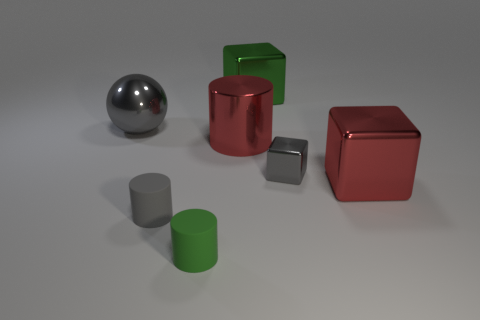Subtract all big metal cubes. How many cubes are left? 1 Add 2 metallic spheres. How many objects exist? 9 Subtract all cylinders. How many objects are left? 4 Subtract 2 cylinders. How many cylinders are left? 1 Subtract all green blocks. How many blocks are left? 2 Add 7 red metallic cubes. How many red metallic cubes exist? 8 Subtract 0 purple cylinders. How many objects are left? 7 Subtract all red blocks. Subtract all brown balls. How many blocks are left? 2 Subtract all cyan cubes. How many green cylinders are left? 1 Subtract all cubes. Subtract all gray metallic cubes. How many objects are left? 3 